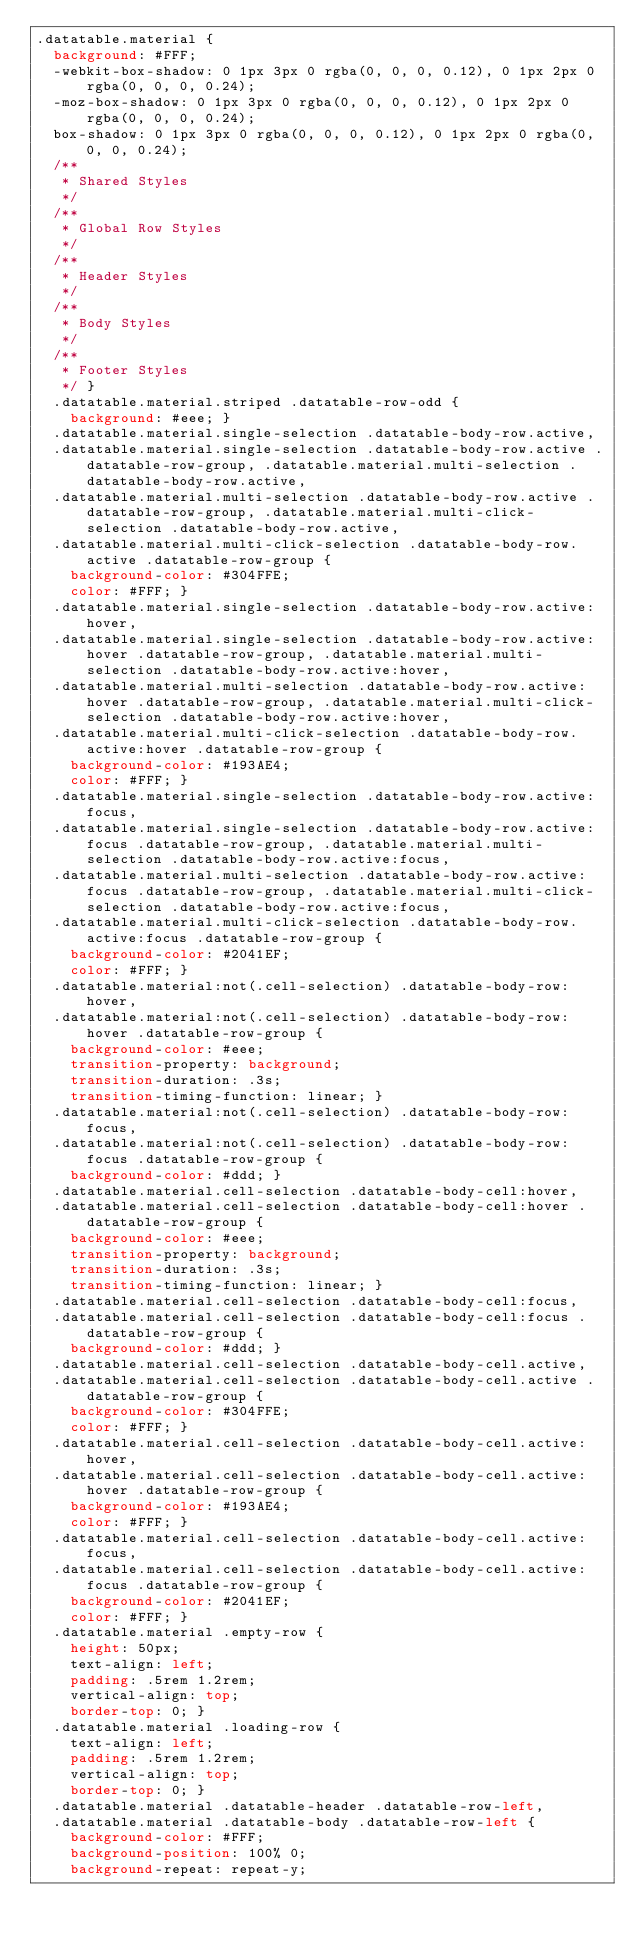Convert code to text. <code><loc_0><loc_0><loc_500><loc_500><_CSS_>.datatable.material {
  background: #FFF;
  -webkit-box-shadow: 0 1px 3px 0 rgba(0, 0, 0, 0.12), 0 1px 2px 0 rgba(0, 0, 0, 0.24);
  -moz-box-shadow: 0 1px 3px 0 rgba(0, 0, 0, 0.12), 0 1px 2px 0 rgba(0, 0, 0, 0.24);
  box-shadow: 0 1px 3px 0 rgba(0, 0, 0, 0.12), 0 1px 2px 0 rgba(0, 0, 0, 0.24);
  /**
	 * Shared Styles
	 */
  /**
	 * Global Row Styles
	 */
  /**
	 * Header Styles
	 */
  /**
	 * Body Styles
	 */
  /**
	 * Footer Styles
	 */ }
  .datatable.material.striped .datatable-row-odd {
    background: #eee; }
  .datatable.material.single-selection .datatable-body-row.active,
  .datatable.material.single-selection .datatable-body-row.active .datatable-row-group, .datatable.material.multi-selection .datatable-body-row.active,
  .datatable.material.multi-selection .datatable-body-row.active .datatable-row-group, .datatable.material.multi-click-selection .datatable-body-row.active,
  .datatable.material.multi-click-selection .datatable-body-row.active .datatable-row-group {
    background-color: #304FFE;
    color: #FFF; }
  .datatable.material.single-selection .datatable-body-row.active:hover,
  .datatable.material.single-selection .datatable-body-row.active:hover .datatable-row-group, .datatable.material.multi-selection .datatable-body-row.active:hover,
  .datatable.material.multi-selection .datatable-body-row.active:hover .datatable-row-group, .datatable.material.multi-click-selection .datatable-body-row.active:hover,
  .datatable.material.multi-click-selection .datatable-body-row.active:hover .datatable-row-group {
    background-color: #193AE4;
    color: #FFF; }
  .datatable.material.single-selection .datatable-body-row.active:focus,
  .datatable.material.single-selection .datatable-body-row.active:focus .datatable-row-group, .datatable.material.multi-selection .datatable-body-row.active:focus,
  .datatable.material.multi-selection .datatable-body-row.active:focus .datatable-row-group, .datatable.material.multi-click-selection .datatable-body-row.active:focus,
  .datatable.material.multi-click-selection .datatable-body-row.active:focus .datatable-row-group {
    background-color: #2041EF;
    color: #FFF; }
  .datatable.material:not(.cell-selection) .datatable-body-row:hover,
  .datatable.material:not(.cell-selection) .datatable-body-row:hover .datatable-row-group {
    background-color: #eee;
    transition-property: background;
    transition-duration: .3s;
    transition-timing-function: linear; }
  .datatable.material:not(.cell-selection) .datatable-body-row:focus,
  .datatable.material:not(.cell-selection) .datatable-body-row:focus .datatable-row-group {
    background-color: #ddd; }
  .datatable.material.cell-selection .datatable-body-cell:hover,
  .datatable.material.cell-selection .datatable-body-cell:hover .datatable-row-group {
    background-color: #eee;
    transition-property: background;
    transition-duration: .3s;
    transition-timing-function: linear; }
  .datatable.material.cell-selection .datatable-body-cell:focus,
  .datatable.material.cell-selection .datatable-body-cell:focus .datatable-row-group {
    background-color: #ddd; }
  .datatable.material.cell-selection .datatable-body-cell.active,
  .datatable.material.cell-selection .datatable-body-cell.active .datatable-row-group {
    background-color: #304FFE;
    color: #FFF; }
  .datatable.material.cell-selection .datatable-body-cell.active:hover,
  .datatable.material.cell-selection .datatable-body-cell.active:hover .datatable-row-group {
    background-color: #193AE4;
    color: #FFF; }
  .datatable.material.cell-selection .datatable-body-cell.active:focus,
  .datatable.material.cell-selection .datatable-body-cell.active:focus .datatable-row-group {
    background-color: #2041EF;
    color: #FFF; }
  .datatable.material .empty-row {
    height: 50px;
    text-align: left;
    padding: .5rem 1.2rem;
    vertical-align: top;
    border-top: 0; }
  .datatable.material .loading-row {
    text-align: left;
    padding: .5rem 1.2rem;
    vertical-align: top;
    border-top: 0; }
  .datatable.material .datatable-header .datatable-row-left,
  .datatable.material .datatable-body .datatable-row-left {
    background-color: #FFF;
    background-position: 100% 0;
    background-repeat: repeat-y;</code> 